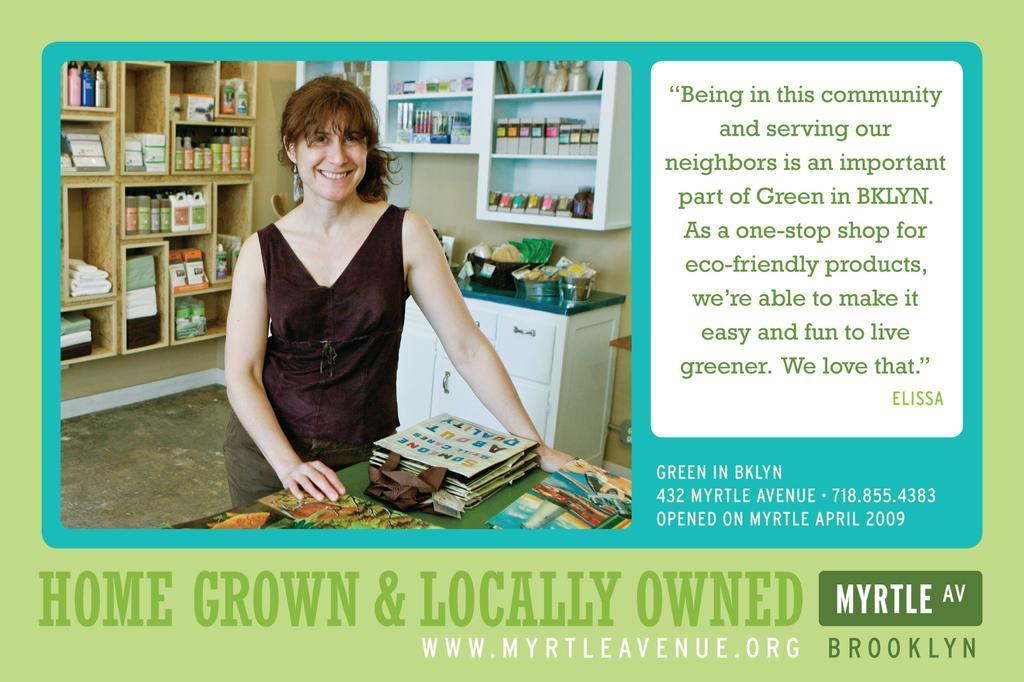How would you summarize this image in a sentence or two? In the picture I can see a woman wearing black dress is standing and there are few objects behind her and there is something written beside and below the image. 